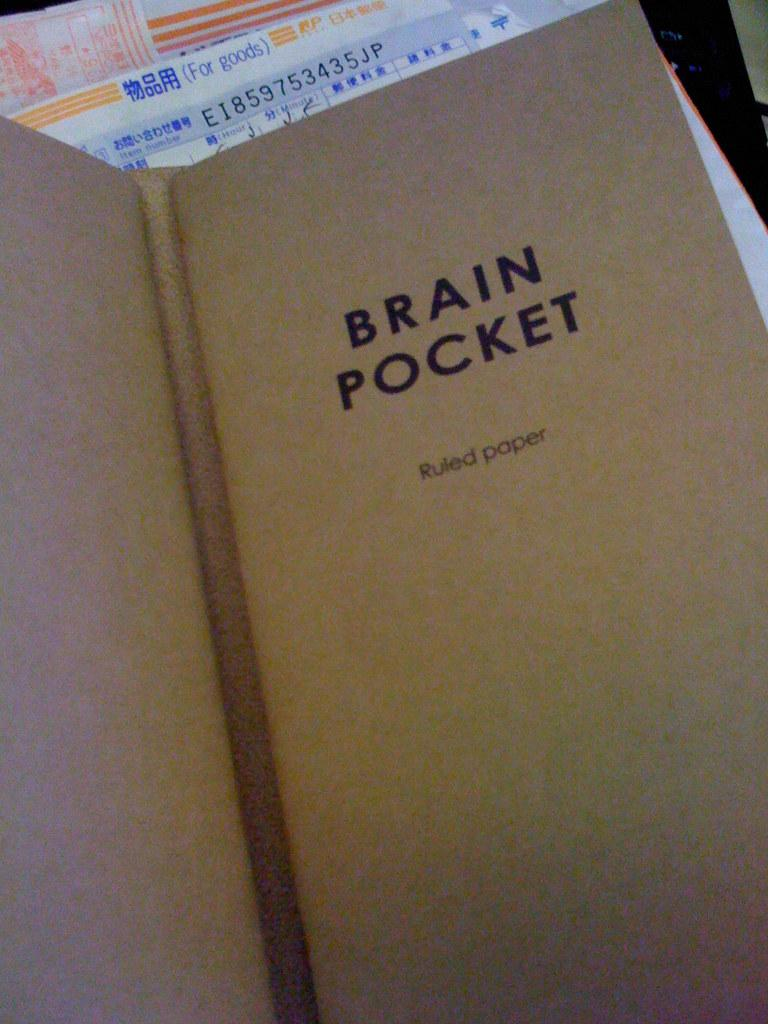<image>
Describe the image concisely. A book of ruled paper by the brand Brain Pocket. 